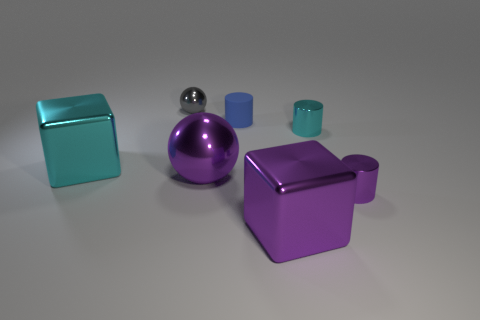Subtract all purple cylinders. How many cylinders are left? 2 Add 1 tiny green metal balls. How many objects exist? 8 Subtract all purple cylinders. How many cylinders are left? 2 Subtract all balls. How many objects are left? 5 Subtract all yellow matte cubes. Subtract all tiny blue cylinders. How many objects are left? 6 Add 7 blue rubber cylinders. How many blue rubber cylinders are left? 8 Add 4 small things. How many small things exist? 8 Subtract 0 brown cylinders. How many objects are left? 7 Subtract all red cylinders. Subtract all yellow balls. How many cylinders are left? 3 